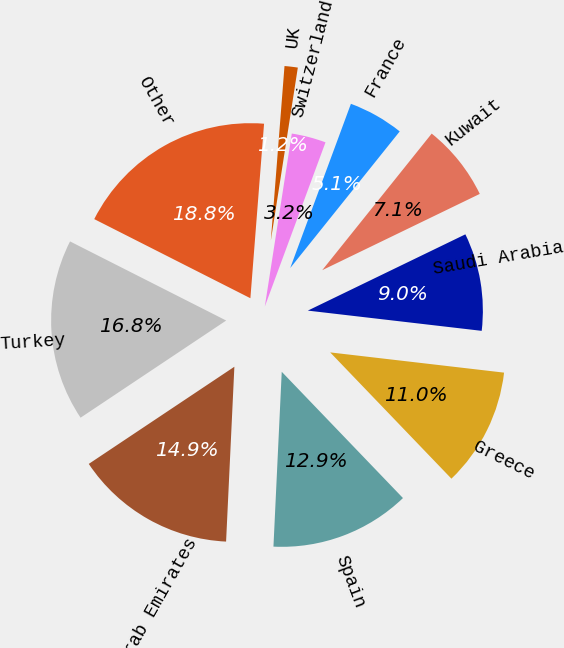Convert chart to OTSL. <chart><loc_0><loc_0><loc_500><loc_500><pie_chart><fcel>Turkey<fcel>United Arab Emirates<fcel>Spain<fcel>Greece<fcel>Saudi Arabia<fcel>Kuwait<fcel>France<fcel>Switzerland<fcel>UK<fcel>Other<nl><fcel>16.83%<fcel>14.88%<fcel>12.93%<fcel>10.98%<fcel>9.02%<fcel>7.07%<fcel>5.12%<fcel>3.17%<fcel>1.22%<fcel>18.78%<nl></chart> 